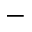<formula> <loc_0><loc_0><loc_500><loc_500>^ { - }</formula> 